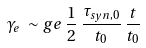Convert formula to latex. <formula><loc_0><loc_0><loc_500><loc_500>\gamma _ { e } \, \sim g e \, \frac { 1 } { 2 } \, \frac { \tau _ { s y n , 0 } } { t _ { 0 } } \, \frac { t } { t _ { 0 } }</formula> 